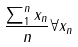Convert formula to latex. <formula><loc_0><loc_0><loc_500><loc_500>\frac { \sum _ { 1 } ^ { n } x _ { n } } { n } \forall x _ { n }</formula> 